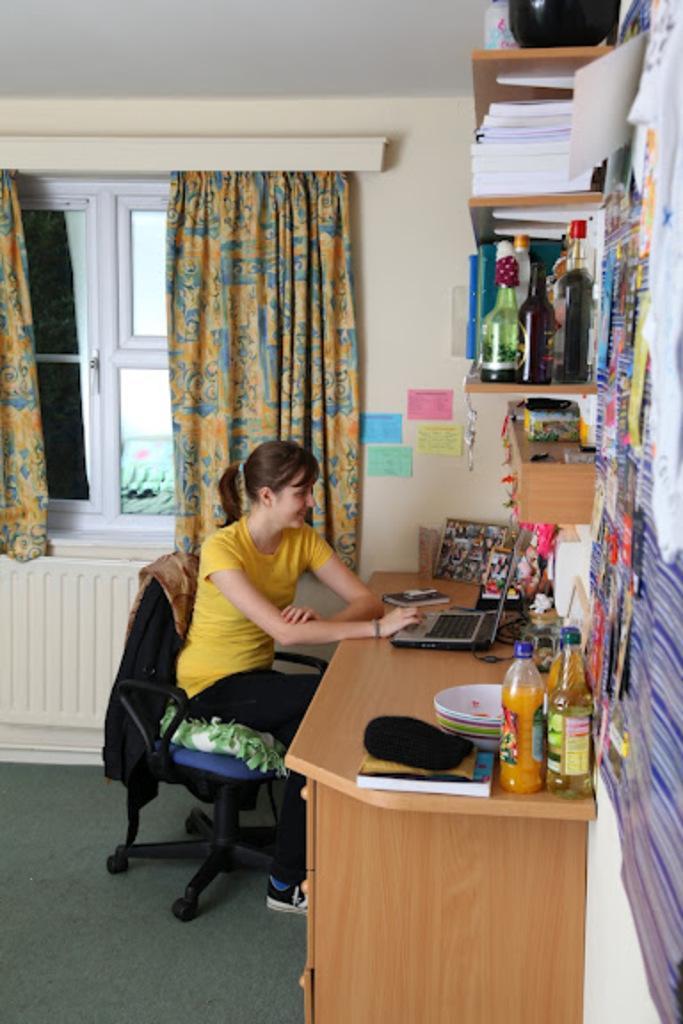Describe this image in one or two sentences. The image is inside the room. In the image there is a woman who is sitting on chair in front of a laptop. On chair we can see some clothes and in front of a woman there is a table on which a laptop is placed. On table we can see bowl,bottle,frames on right side there is a shelf on shelf we can see some bottles,books,jar,wall,papers in middle there is a window which is closed and curtains. 